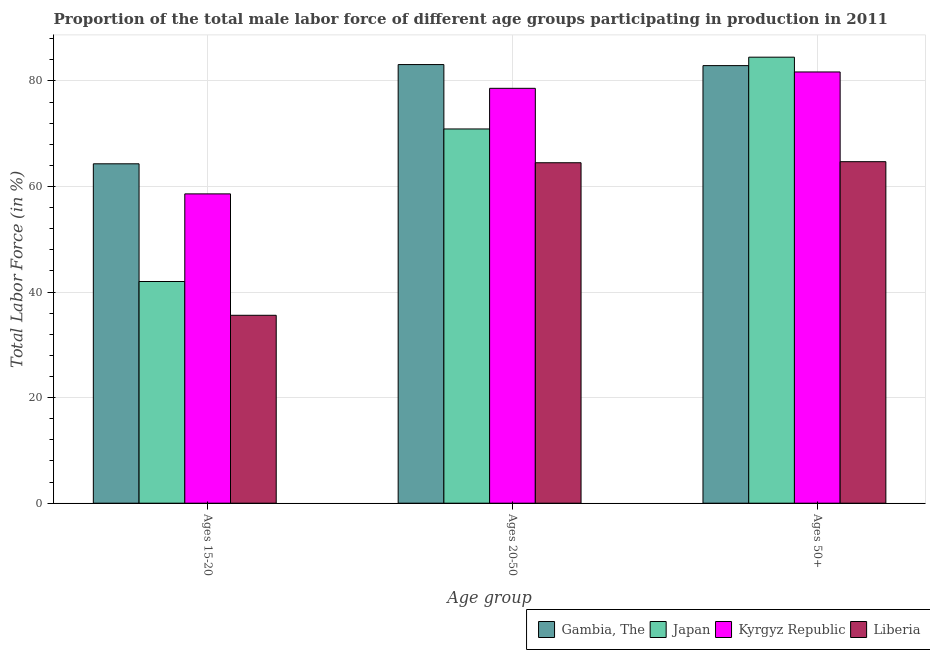Are the number of bars on each tick of the X-axis equal?
Provide a short and direct response. Yes. How many bars are there on the 3rd tick from the left?
Offer a terse response. 4. How many bars are there on the 2nd tick from the right?
Make the answer very short. 4. What is the label of the 3rd group of bars from the left?
Make the answer very short. Ages 50+. What is the percentage of male labor force within the age group 15-20 in Gambia, The?
Ensure brevity in your answer.  64.3. Across all countries, what is the maximum percentage of male labor force above age 50?
Ensure brevity in your answer.  84.5. Across all countries, what is the minimum percentage of male labor force within the age group 15-20?
Provide a succinct answer. 35.6. In which country was the percentage of male labor force above age 50 minimum?
Your answer should be very brief. Liberia. What is the total percentage of male labor force within the age group 15-20 in the graph?
Your answer should be compact. 200.5. What is the difference between the percentage of male labor force within the age group 15-20 in Gambia, The and that in Liberia?
Ensure brevity in your answer.  28.7. What is the difference between the percentage of male labor force within the age group 15-20 in Japan and the percentage of male labor force above age 50 in Gambia, The?
Make the answer very short. -40.9. What is the average percentage of male labor force within the age group 15-20 per country?
Keep it short and to the point. 50.12. What is the difference between the percentage of male labor force within the age group 20-50 and percentage of male labor force within the age group 15-20 in Kyrgyz Republic?
Your response must be concise. 20. What is the ratio of the percentage of male labor force above age 50 in Gambia, The to that in Kyrgyz Republic?
Keep it short and to the point. 1.01. Is the percentage of male labor force within the age group 20-50 in Liberia less than that in Japan?
Provide a short and direct response. Yes. Is the difference between the percentage of male labor force within the age group 15-20 in Gambia, The and Kyrgyz Republic greater than the difference between the percentage of male labor force within the age group 20-50 in Gambia, The and Kyrgyz Republic?
Keep it short and to the point. Yes. What is the difference between the highest and the second highest percentage of male labor force above age 50?
Provide a short and direct response. 1.6. What is the difference between the highest and the lowest percentage of male labor force within the age group 20-50?
Your response must be concise. 18.6. What does the 3rd bar from the right in Ages 15-20 represents?
Provide a succinct answer. Japan. How many bars are there?
Give a very brief answer. 12. What is the difference between two consecutive major ticks on the Y-axis?
Provide a succinct answer. 20. Does the graph contain any zero values?
Offer a very short reply. No. Does the graph contain grids?
Give a very brief answer. Yes. What is the title of the graph?
Provide a succinct answer. Proportion of the total male labor force of different age groups participating in production in 2011. Does "American Samoa" appear as one of the legend labels in the graph?
Offer a terse response. No. What is the label or title of the X-axis?
Give a very brief answer. Age group. What is the Total Labor Force (in %) in Gambia, The in Ages 15-20?
Your answer should be compact. 64.3. What is the Total Labor Force (in %) in Kyrgyz Republic in Ages 15-20?
Your answer should be compact. 58.6. What is the Total Labor Force (in %) in Liberia in Ages 15-20?
Your answer should be compact. 35.6. What is the Total Labor Force (in %) in Gambia, The in Ages 20-50?
Ensure brevity in your answer.  83.1. What is the Total Labor Force (in %) in Japan in Ages 20-50?
Make the answer very short. 70.9. What is the Total Labor Force (in %) in Kyrgyz Republic in Ages 20-50?
Provide a succinct answer. 78.6. What is the Total Labor Force (in %) in Liberia in Ages 20-50?
Your answer should be compact. 64.5. What is the Total Labor Force (in %) in Gambia, The in Ages 50+?
Offer a very short reply. 82.9. What is the Total Labor Force (in %) in Japan in Ages 50+?
Offer a very short reply. 84.5. What is the Total Labor Force (in %) in Kyrgyz Republic in Ages 50+?
Provide a succinct answer. 81.7. What is the Total Labor Force (in %) of Liberia in Ages 50+?
Offer a very short reply. 64.7. Across all Age group, what is the maximum Total Labor Force (in %) in Gambia, The?
Keep it short and to the point. 83.1. Across all Age group, what is the maximum Total Labor Force (in %) in Japan?
Offer a terse response. 84.5. Across all Age group, what is the maximum Total Labor Force (in %) in Kyrgyz Republic?
Offer a terse response. 81.7. Across all Age group, what is the maximum Total Labor Force (in %) in Liberia?
Provide a succinct answer. 64.7. Across all Age group, what is the minimum Total Labor Force (in %) of Gambia, The?
Offer a very short reply. 64.3. Across all Age group, what is the minimum Total Labor Force (in %) of Japan?
Offer a very short reply. 42. Across all Age group, what is the minimum Total Labor Force (in %) of Kyrgyz Republic?
Give a very brief answer. 58.6. Across all Age group, what is the minimum Total Labor Force (in %) in Liberia?
Your response must be concise. 35.6. What is the total Total Labor Force (in %) in Gambia, The in the graph?
Keep it short and to the point. 230.3. What is the total Total Labor Force (in %) in Japan in the graph?
Make the answer very short. 197.4. What is the total Total Labor Force (in %) of Kyrgyz Republic in the graph?
Keep it short and to the point. 218.9. What is the total Total Labor Force (in %) in Liberia in the graph?
Give a very brief answer. 164.8. What is the difference between the Total Labor Force (in %) in Gambia, The in Ages 15-20 and that in Ages 20-50?
Ensure brevity in your answer.  -18.8. What is the difference between the Total Labor Force (in %) of Japan in Ages 15-20 and that in Ages 20-50?
Give a very brief answer. -28.9. What is the difference between the Total Labor Force (in %) in Liberia in Ages 15-20 and that in Ages 20-50?
Ensure brevity in your answer.  -28.9. What is the difference between the Total Labor Force (in %) of Gambia, The in Ages 15-20 and that in Ages 50+?
Ensure brevity in your answer.  -18.6. What is the difference between the Total Labor Force (in %) in Japan in Ages 15-20 and that in Ages 50+?
Keep it short and to the point. -42.5. What is the difference between the Total Labor Force (in %) of Kyrgyz Republic in Ages 15-20 and that in Ages 50+?
Keep it short and to the point. -23.1. What is the difference between the Total Labor Force (in %) of Liberia in Ages 15-20 and that in Ages 50+?
Your response must be concise. -29.1. What is the difference between the Total Labor Force (in %) in Gambia, The in Ages 20-50 and that in Ages 50+?
Offer a very short reply. 0.2. What is the difference between the Total Labor Force (in %) of Kyrgyz Republic in Ages 20-50 and that in Ages 50+?
Offer a terse response. -3.1. What is the difference between the Total Labor Force (in %) of Liberia in Ages 20-50 and that in Ages 50+?
Your response must be concise. -0.2. What is the difference between the Total Labor Force (in %) in Gambia, The in Ages 15-20 and the Total Labor Force (in %) in Japan in Ages 20-50?
Ensure brevity in your answer.  -6.6. What is the difference between the Total Labor Force (in %) of Gambia, The in Ages 15-20 and the Total Labor Force (in %) of Kyrgyz Republic in Ages 20-50?
Ensure brevity in your answer.  -14.3. What is the difference between the Total Labor Force (in %) of Japan in Ages 15-20 and the Total Labor Force (in %) of Kyrgyz Republic in Ages 20-50?
Your answer should be very brief. -36.6. What is the difference between the Total Labor Force (in %) in Japan in Ages 15-20 and the Total Labor Force (in %) in Liberia in Ages 20-50?
Provide a succinct answer. -22.5. What is the difference between the Total Labor Force (in %) in Gambia, The in Ages 15-20 and the Total Labor Force (in %) in Japan in Ages 50+?
Keep it short and to the point. -20.2. What is the difference between the Total Labor Force (in %) in Gambia, The in Ages 15-20 and the Total Labor Force (in %) in Kyrgyz Republic in Ages 50+?
Provide a short and direct response. -17.4. What is the difference between the Total Labor Force (in %) in Gambia, The in Ages 15-20 and the Total Labor Force (in %) in Liberia in Ages 50+?
Provide a succinct answer. -0.4. What is the difference between the Total Labor Force (in %) of Japan in Ages 15-20 and the Total Labor Force (in %) of Kyrgyz Republic in Ages 50+?
Your answer should be very brief. -39.7. What is the difference between the Total Labor Force (in %) in Japan in Ages 15-20 and the Total Labor Force (in %) in Liberia in Ages 50+?
Your answer should be compact. -22.7. What is the difference between the Total Labor Force (in %) of Japan in Ages 20-50 and the Total Labor Force (in %) of Liberia in Ages 50+?
Make the answer very short. 6.2. What is the difference between the Total Labor Force (in %) of Kyrgyz Republic in Ages 20-50 and the Total Labor Force (in %) of Liberia in Ages 50+?
Your answer should be compact. 13.9. What is the average Total Labor Force (in %) of Gambia, The per Age group?
Your answer should be very brief. 76.77. What is the average Total Labor Force (in %) in Japan per Age group?
Give a very brief answer. 65.8. What is the average Total Labor Force (in %) of Kyrgyz Republic per Age group?
Offer a very short reply. 72.97. What is the average Total Labor Force (in %) in Liberia per Age group?
Offer a very short reply. 54.93. What is the difference between the Total Labor Force (in %) in Gambia, The and Total Labor Force (in %) in Japan in Ages 15-20?
Your answer should be compact. 22.3. What is the difference between the Total Labor Force (in %) in Gambia, The and Total Labor Force (in %) in Kyrgyz Republic in Ages 15-20?
Keep it short and to the point. 5.7. What is the difference between the Total Labor Force (in %) of Gambia, The and Total Labor Force (in %) of Liberia in Ages 15-20?
Offer a terse response. 28.7. What is the difference between the Total Labor Force (in %) in Japan and Total Labor Force (in %) in Kyrgyz Republic in Ages 15-20?
Offer a terse response. -16.6. What is the difference between the Total Labor Force (in %) in Japan and Total Labor Force (in %) in Liberia in Ages 15-20?
Your answer should be compact. 6.4. What is the difference between the Total Labor Force (in %) in Kyrgyz Republic and Total Labor Force (in %) in Liberia in Ages 15-20?
Ensure brevity in your answer.  23. What is the difference between the Total Labor Force (in %) in Gambia, The and Total Labor Force (in %) in Japan in Ages 20-50?
Your answer should be very brief. 12.2. What is the difference between the Total Labor Force (in %) in Japan and Total Labor Force (in %) in Liberia in Ages 20-50?
Keep it short and to the point. 6.4. What is the difference between the Total Labor Force (in %) of Kyrgyz Republic and Total Labor Force (in %) of Liberia in Ages 20-50?
Offer a very short reply. 14.1. What is the difference between the Total Labor Force (in %) of Gambia, The and Total Labor Force (in %) of Japan in Ages 50+?
Give a very brief answer. -1.6. What is the difference between the Total Labor Force (in %) of Japan and Total Labor Force (in %) of Kyrgyz Republic in Ages 50+?
Ensure brevity in your answer.  2.8. What is the difference between the Total Labor Force (in %) of Japan and Total Labor Force (in %) of Liberia in Ages 50+?
Provide a short and direct response. 19.8. What is the ratio of the Total Labor Force (in %) in Gambia, The in Ages 15-20 to that in Ages 20-50?
Your answer should be compact. 0.77. What is the ratio of the Total Labor Force (in %) in Japan in Ages 15-20 to that in Ages 20-50?
Provide a succinct answer. 0.59. What is the ratio of the Total Labor Force (in %) of Kyrgyz Republic in Ages 15-20 to that in Ages 20-50?
Your response must be concise. 0.75. What is the ratio of the Total Labor Force (in %) of Liberia in Ages 15-20 to that in Ages 20-50?
Keep it short and to the point. 0.55. What is the ratio of the Total Labor Force (in %) of Gambia, The in Ages 15-20 to that in Ages 50+?
Keep it short and to the point. 0.78. What is the ratio of the Total Labor Force (in %) in Japan in Ages 15-20 to that in Ages 50+?
Your response must be concise. 0.5. What is the ratio of the Total Labor Force (in %) of Kyrgyz Republic in Ages 15-20 to that in Ages 50+?
Keep it short and to the point. 0.72. What is the ratio of the Total Labor Force (in %) of Liberia in Ages 15-20 to that in Ages 50+?
Offer a very short reply. 0.55. What is the ratio of the Total Labor Force (in %) of Gambia, The in Ages 20-50 to that in Ages 50+?
Give a very brief answer. 1. What is the ratio of the Total Labor Force (in %) of Japan in Ages 20-50 to that in Ages 50+?
Offer a very short reply. 0.84. What is the ratio of the Total Labor Force (in %) in Kyrgyz Republic in Ages 20-50 to that in Ages 50+?
Offer a very short reply. 0.96. What is the difference between the highest and the second highest Total Labor Force (in %) in Liberia?
Provide a short and direct response. 0.2. What is the difference between the highest and the lowest Total Labor Force (in %) in Japan?
Offer a very short reply. 42.5. What is the difference between the highest and the lowest Total Labor Force (in %) in Kyrgyz Republic?
Provide a succinct answer. 23.1. What is the difference between the highest and the lowest Total Labor Force (in %) of Liberia?
Keep it short and to the point. 29.1. 